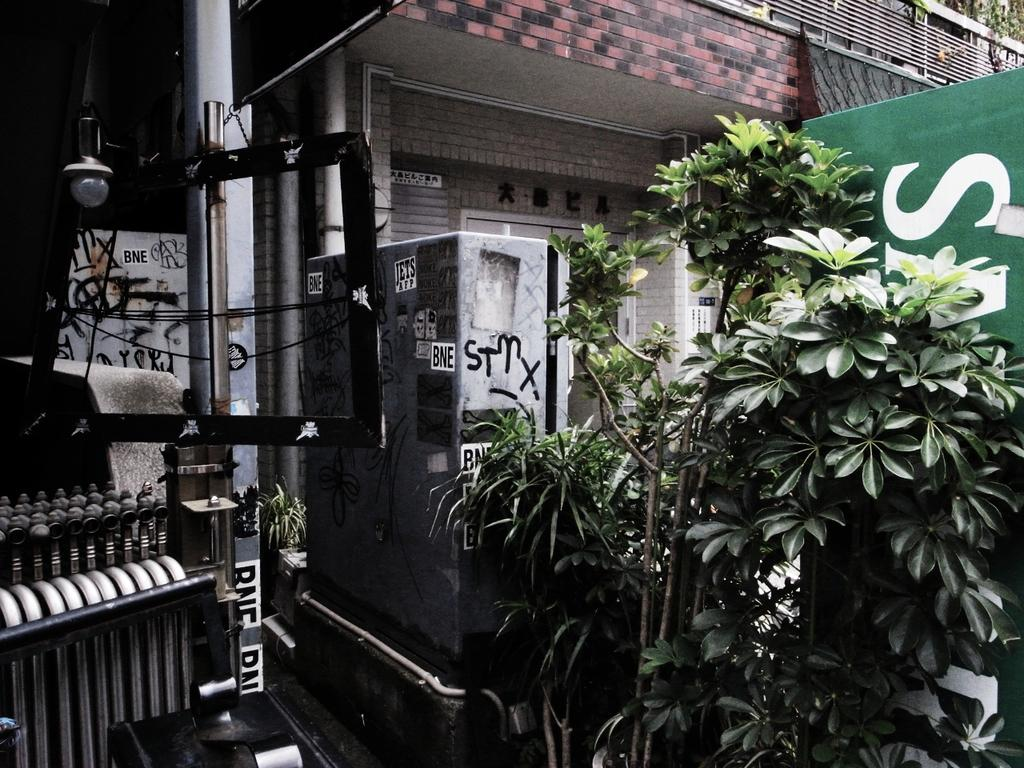What type of structures can be seen in the image? There are buildings in the image. What object is located in the front of the image? There is a box in the front of the image. What type of vegetation is present to the right of the image? There are plants to the right of the image. What architectural feature can be seen to the left of the image? There is a pillar to the left of the image. Where is the beggar sitting in the middle of the image? There is no beggar present in the image. What type of meeting is taking place in the image? There is no meeting depicted in the image. 